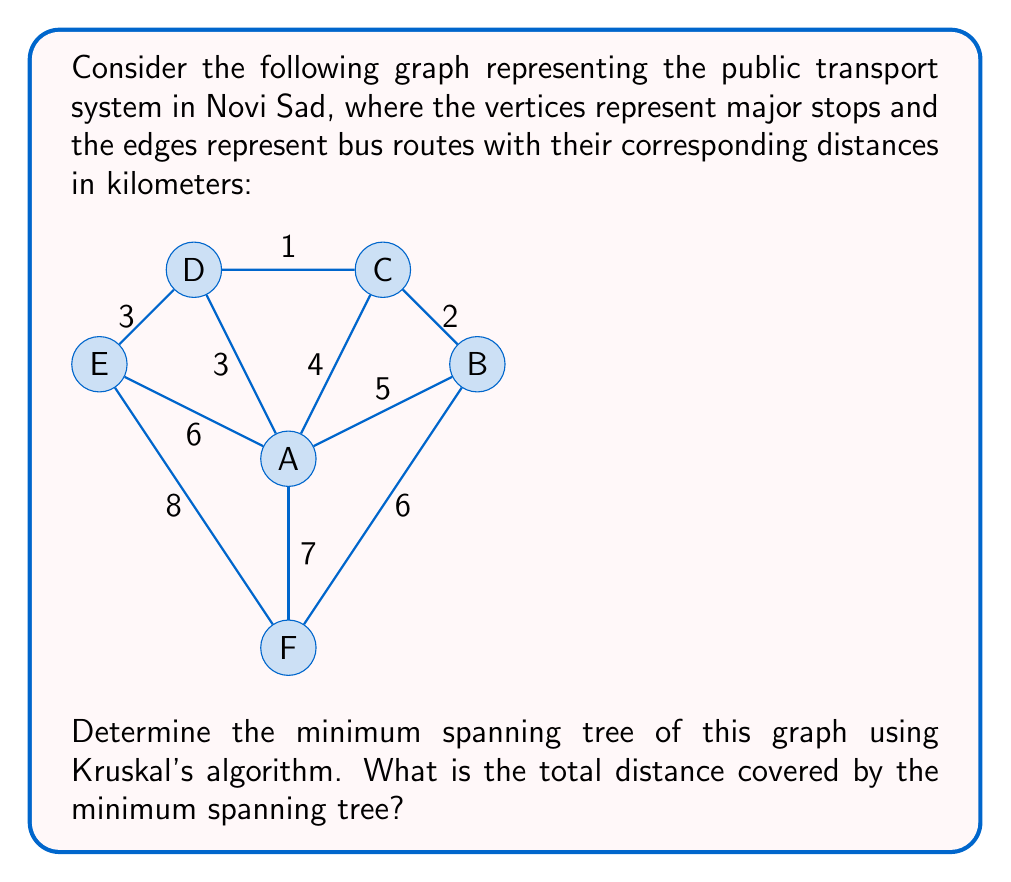Could you help me with this problem? To solve this problem, we'll apply Kruskal's algorithm to find the minimum spanning tree (MST) of the given graph. Kruskal's algorithm works by sorting all edges by weight and then adding them to the MST one by one, skipping any edge that would create a cycle.

Step 1: Sort the edges by weight (distance) in ascending order:
1. C-D (1 km)
2. B-C (2 km)
3. A-D (3 km)
4. D-E (3 km)
5. A-C (4 km)
6. A-B (5 km)
7. A-E (6 km)
8. B-F (6 km)
9. A-F (7 km)
10. E-F (8 km)

Step 2: Add edges to the MST, avoiding cycles:
1. Add C-D (1 km)
2. Add B-C (2 km)
3. Add A-D (3 km)
4. Add D-E (3 km)
5. Skip A-C (would create a cycle)
6. Skip A-B (would create a cycle)
7. Skip A-E (would create a cycle)
8. Add B-F (6 km)

At this point, we have added 5 edges, which is sufficient for a minimum spanning tree of a graph with 6 vertices.

The resulting minimum spanning tree is:
$$ MST = \{(C,D), (B,C), (A,D), (D,E), (B,F)\} $$

To calculate the total distance covered by the MST, we sum the weights of the selected edges:

$$ \text{Total distance} = 1 + 2 + 3 + 3 + 6 = 15 \text{ km} $$
Answer: The minimum spanning tree has a total distance of 15 km. 